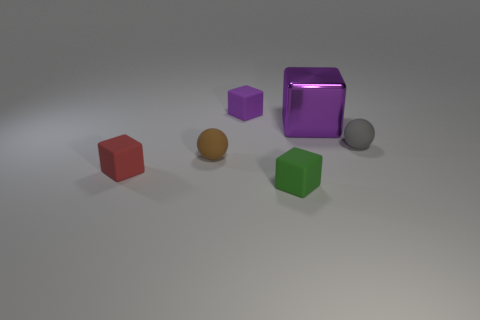Subtract all purple matte cubes. How many cubes are left? 3 Subtract all red cubes. How many cubes are left? 3 Add 1 big gray matte cubes. How many objects exist? 7 Subtract all cubes. How many objects are left? 2 Subtract 1 blocks. How many blocks are left? 3 Subtract all red balls. Subtract all green cylinders. How many balls are left? 2 Subtract all blue spheres. How many green blocks are left? 1 Subtract all tiny gray objects. Subtract all balls. How many objects are left? 3 Add 6 big purple blocks. How many big purple blocks are left? 7 Add 2 big green metal objects. How many big green metal objects exist? 2 